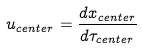<formula> <loc_0><loc_0><loc_500><loc_500>u _ { c e n t e r } = \frac { d x _ { c e n t e r } } { d \tau _ { c e n t e r } }</formula> 